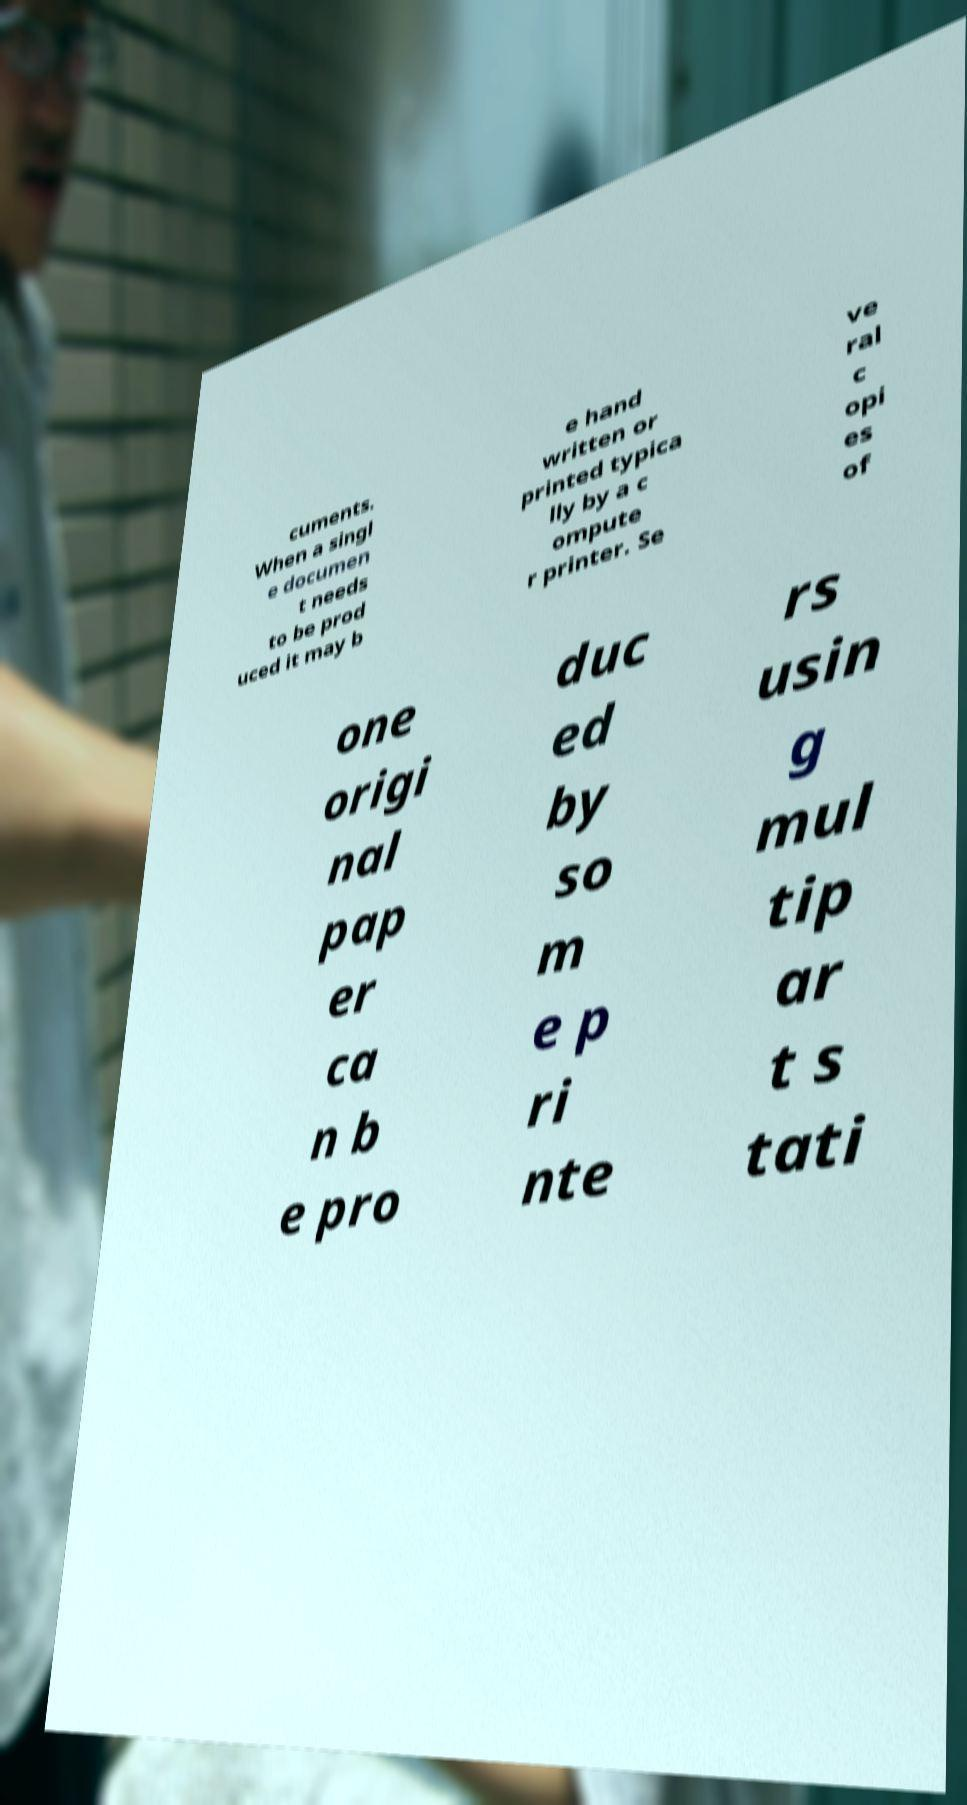Could you extract and type out the text from this image? cuments. When a singl e documen t needs to be prod uced it may b e hand written or printed typica lly by a c ompute r printer. Se ve ral c opi es of one origi nal pap er ca n b e pro duc ed by so m e p ri nte rs usin g mul tip ar t s tati 